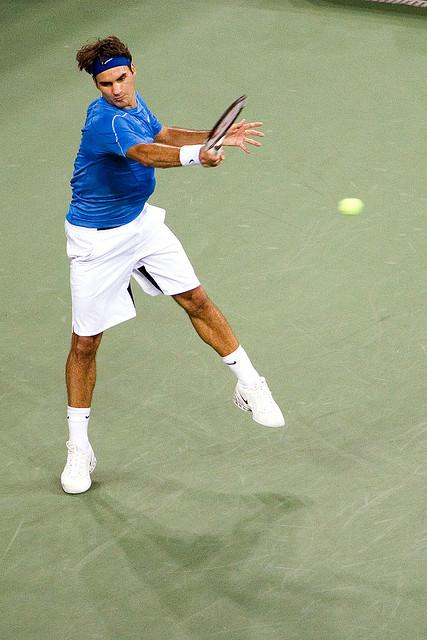What did this tennis player just do? hit ball 